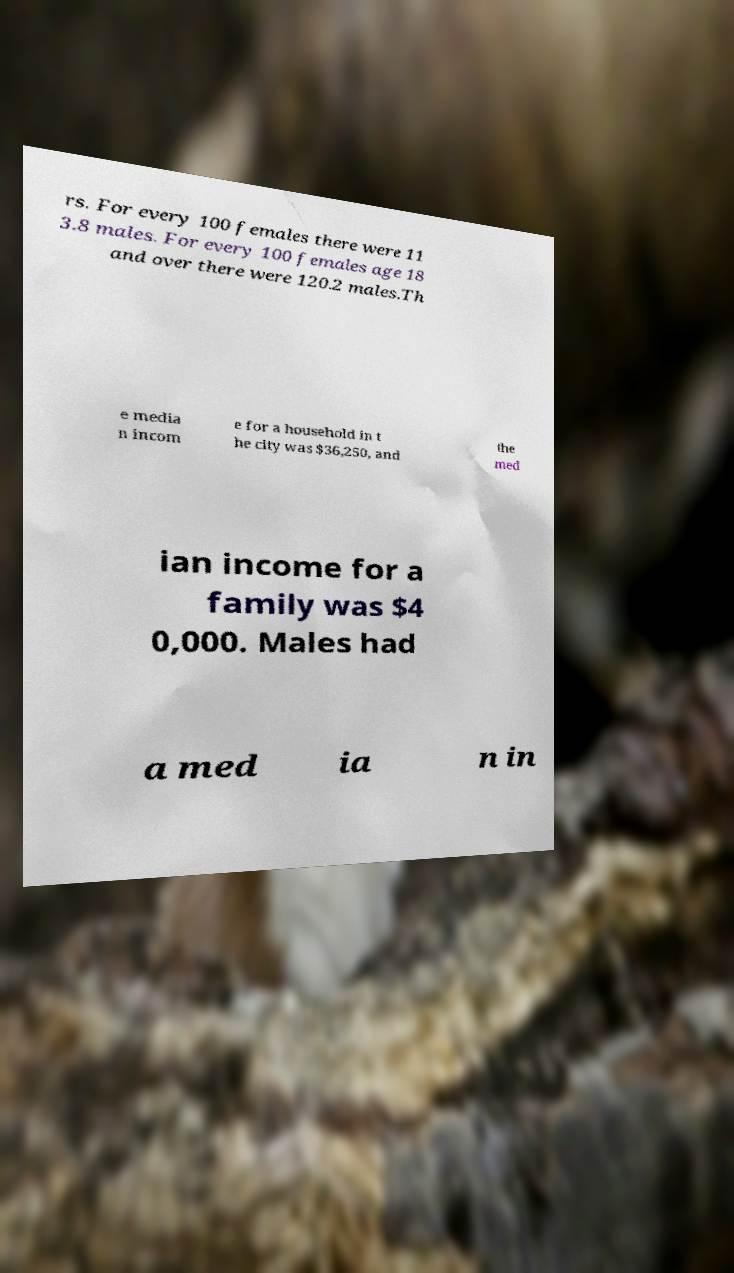For documentation purposes, I need the text within this image transcribed. Could you provide that? rs. For every 100 females there were 11 3.8 males. For every 100 females age 18 and over there were 120.2 males.Th e media n incom e for a household in t he city was $36,250, and the med ian income for a family was $4 0,000. Males had a med ia n in 